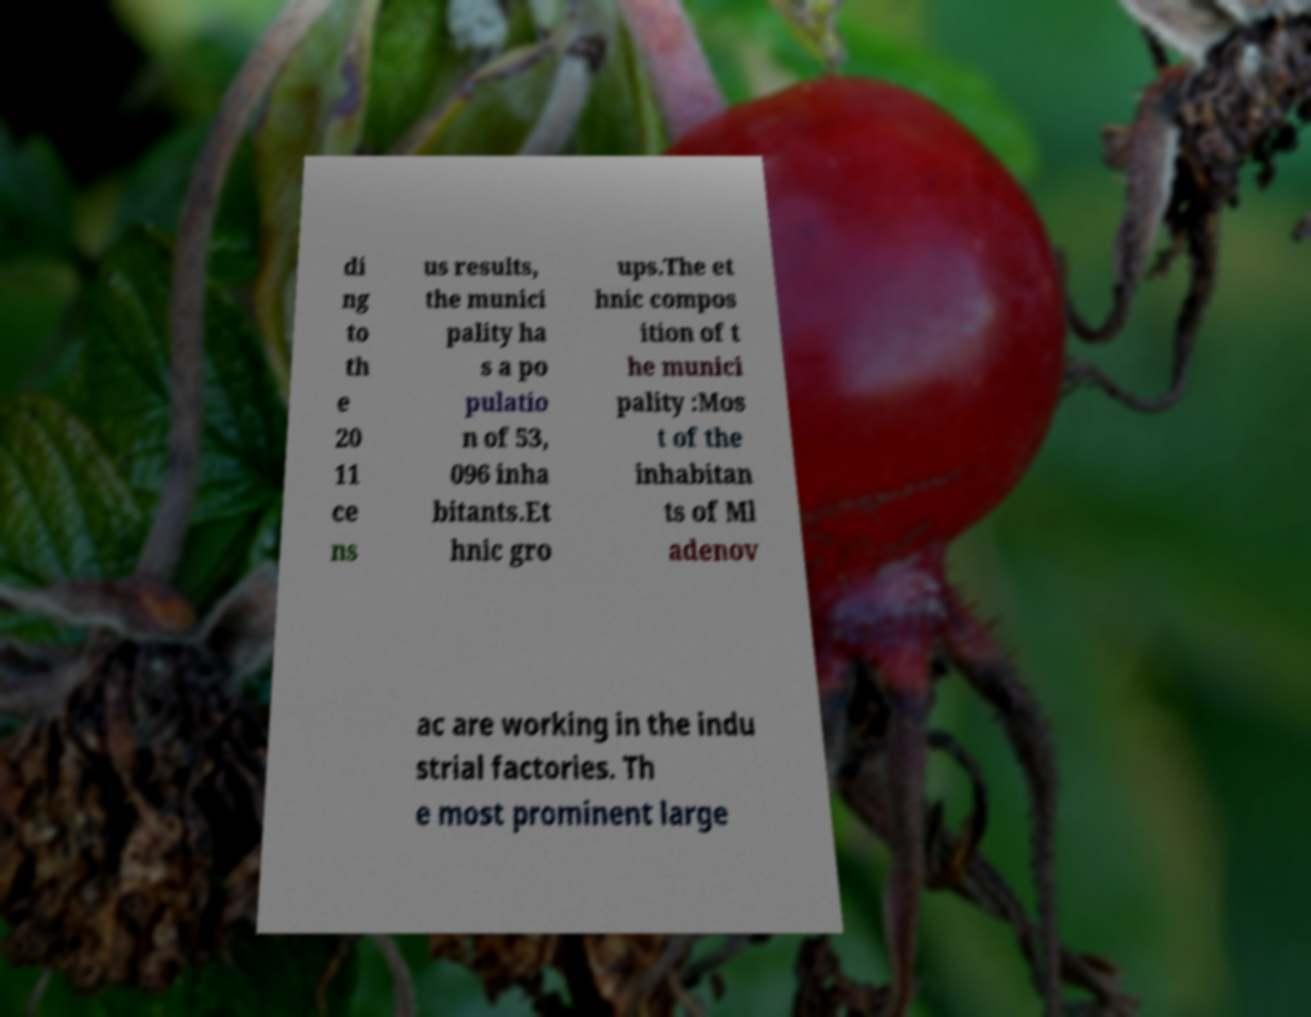There's text embedded in this image that I need extracted. Can you transcribe it verbatim? di ng to th e 20 11 ce ns us results, the munici pality ha s a po pulatio n of 53, 096 inha bitants.Et hnic gro ups.The et hnic compos ition of t he munici pality :Mos t of the inhabitan ts of Ml adenov ac are working in the indu strial factories. Th e most prominent large 